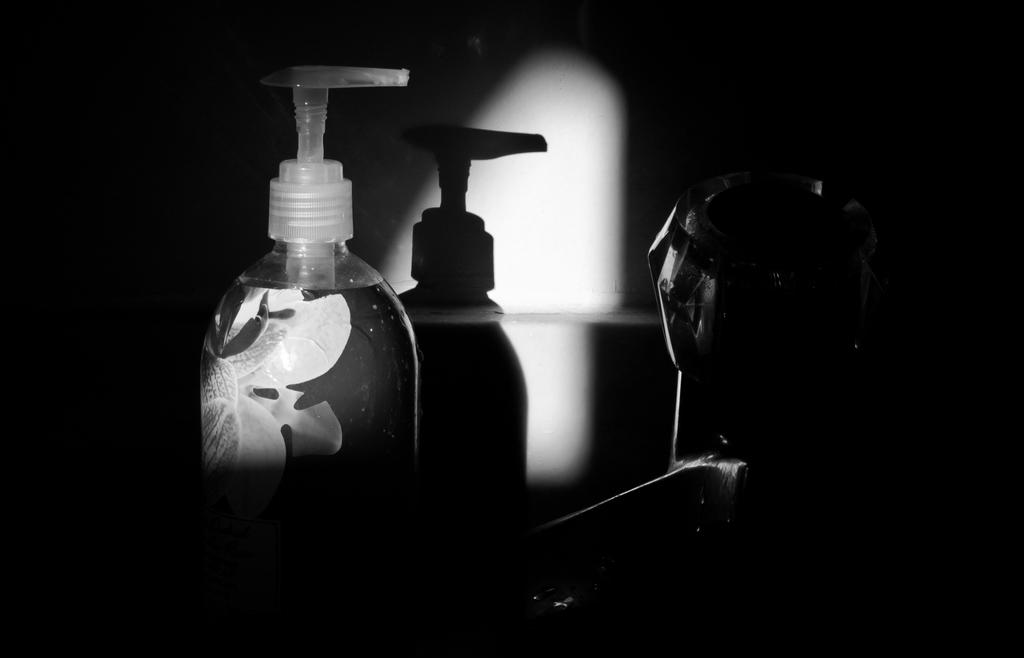What is the main object in the image? There is a bottle in the image. Can you describe any other objects in the image? There is an object in the image, but its details are not specified. What can be observed about the bottle's shadow in the image? The shadow of a bottle is visible on a wall in the image. How would you describe the overall lighting in the image? The image is dark. What type of respect can be seen in the image? There is no indication of respect in the image; it features a bottle and its shadow on a wall. What type of coal is visible in the image? There is no coal present in the image. 